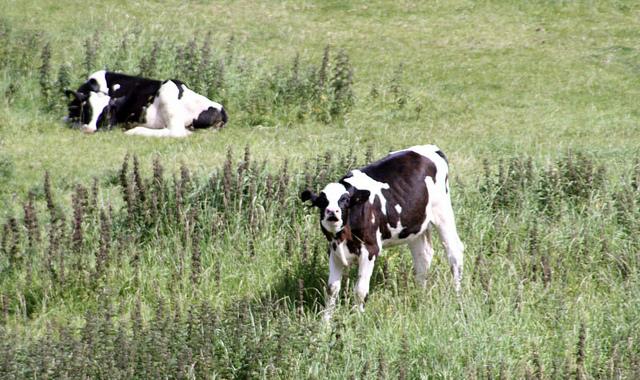What kind of cows are these?
Quick response, please. Holstein. What is the sex of the animals?
Keep it brief. Female. What part of the cow standing up is hidden?
Answer briefly. Feet. 